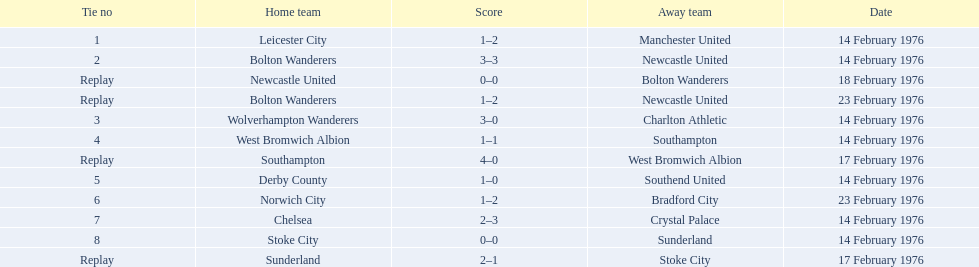What was the score difference in the contest on february 18th? 0. 